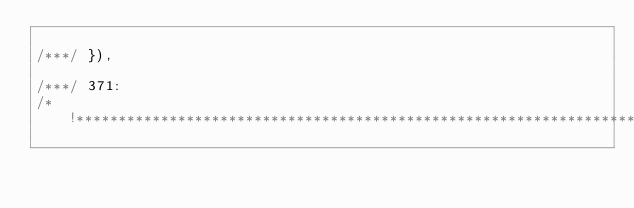Convert code to text. <code><loc_0><loc_0><loc_500><loc_500><_JavaScript_>
/***/ }),

/***/ 371:
/*!*********************************************************************************************************************************************************************************************************************************************************************************************************************************************************************************************************************************************************************************************************!*\</code> 